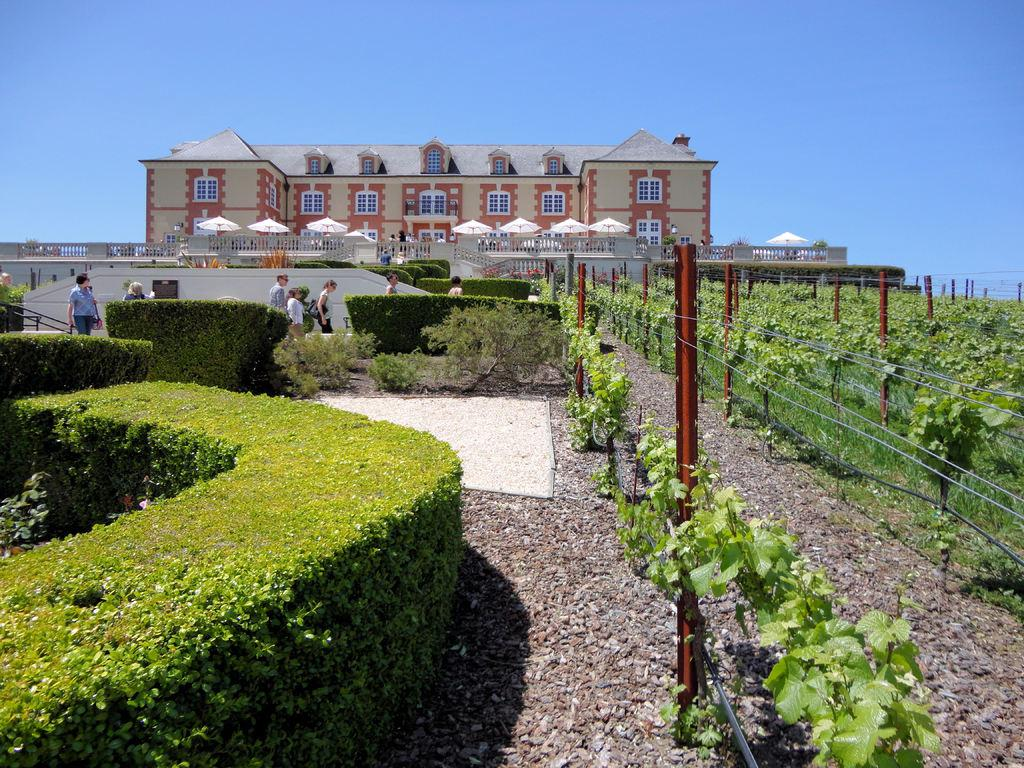What type of living organisms can be seen in the image? Plants can be seen in the image. Can you describe the human in the image? There is a human in the image, but no specific details about their appearance or actions are provided. What type of barrier is present in the image? There is fencing in the image. What is the main setting of the image? The image features a field. What is visible in the background of the image? There is a building in the background of the image. What part of the natural environment is visible in the image? The sky is present at the top of the image. How many tomatoes are growing on the plants in the image? There is no mention of tomatoes in the image; only plants are mentioned. What type of stick is being used by the human in the image? There is no stick present in the image, nor is there any information about the human's actions or possessions. 